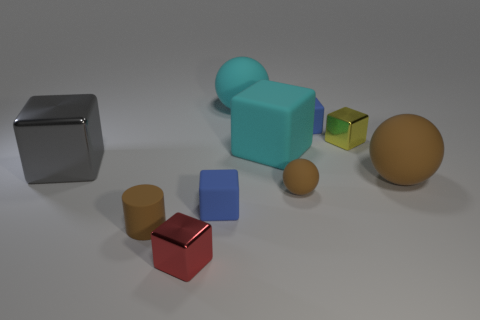Is the material of the red block the same as the gray block in front of the large matte cube? yes 